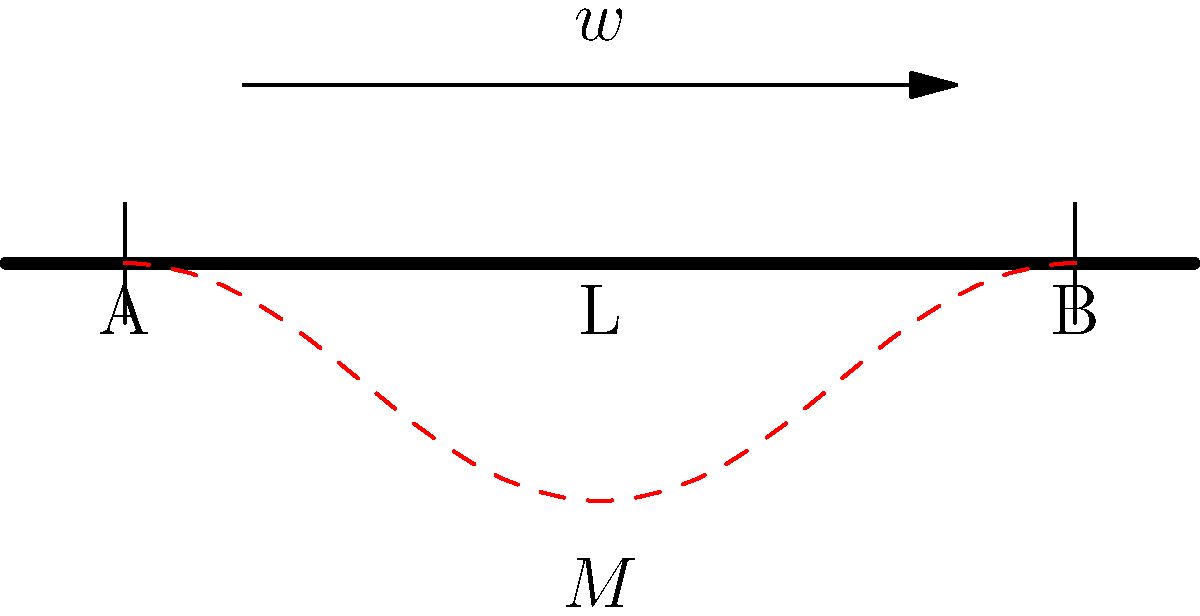In the simply supported concrete beam shown above, subjected to a uniformly distributed load $w$, what is the maximum bending moment $M_{max}$ in terms of $w$ and the beam length $L$? To find the maximum bending moment in a simply supported beam with a uniformly distributed load, we can follow these steps:

1) First, we need to determine the reaction forces at the supports. Due to symmetry, each support will bear half of the total load.

   $R_A = R_B = \frac{wL}{2}$

2) The maximum bending moment occurs at the center of the beam (at $L/2$). We can calculate this using the method of sections:

   $M_{max} = R_A \cdot \frac{L}{2} - w \cdot \frac{L}{2} \cdot \frac{L}{4}$

3) Substituting the value of $R_A$:

   $M_{max} = \frac{wL}{2} \cdot \frac{L}{2} - w \cdot \frac{L}{2} \cdot \frac{L}{4}$

4) Simplifying:

   $M_{max} = \frac{wL^2}{4} - \frac{wL^2}{8} = \frac{wL^2}{8}$

Therefore, the maximum bending moment in the beam is $\frac{wL^2}{8}$.
Answer: $\frac{wL^2}{8}$ 